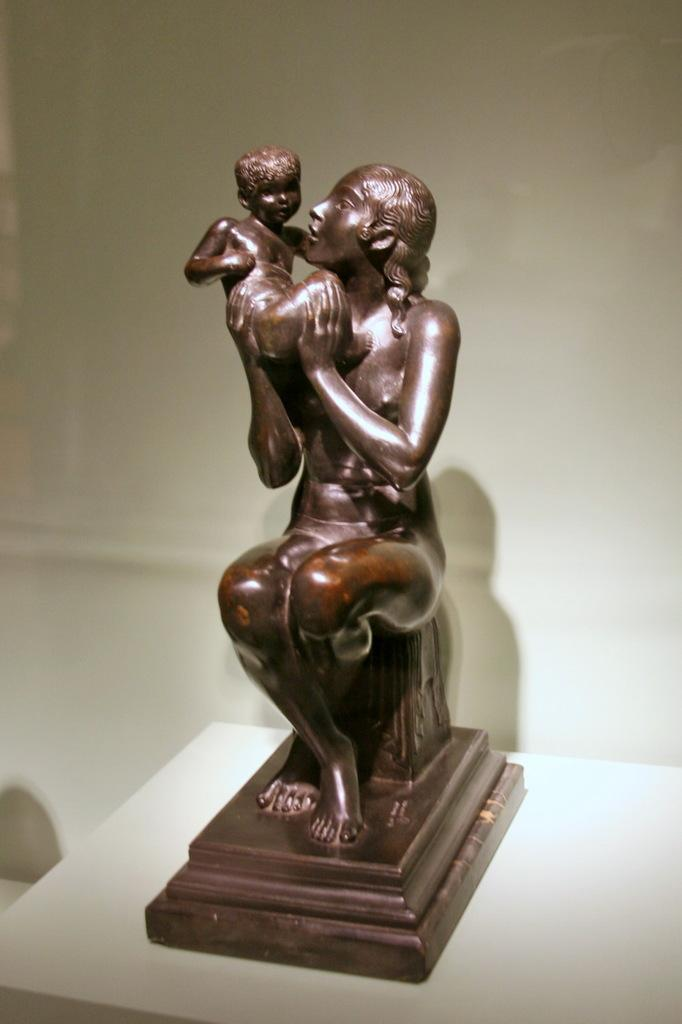What is placed on the table in the image? There is an idol placed on a table in the image. Can you describe the idol? The idol is of a person carrying a baby in their hands. What can be seen in the background of the image? There is a wall in the background of the image. What type of rabbit can be seen playing with the baby in the idol? There is no rabbit present in the image; the idol depicts a person carrying a baby in their hands. 